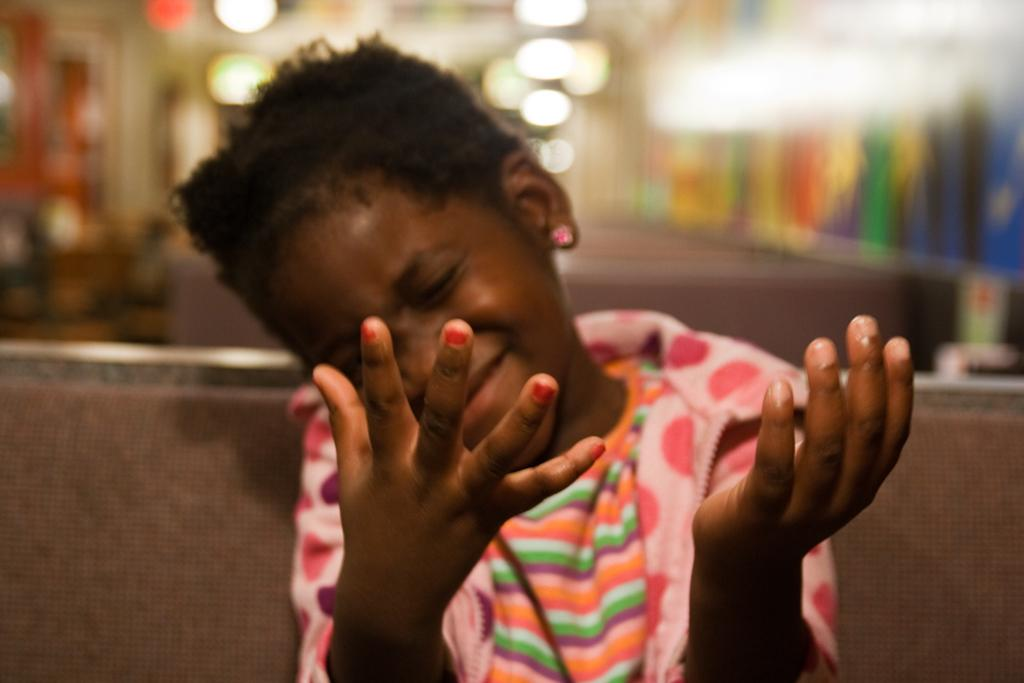What is the main subject of the image? The main subject of the image is a kid. What is the kid wearing in the image? The kid is wearing a pink dress in the image. What action is the kid performing in the image? The kid is showing her hands in the image. Can you describe the background of the image? The background behind the kid is blurred in the image. What type of meat is the kid holding in her hands in the image? There is no meat present in the image; the kid is showing her hands without any objects. 